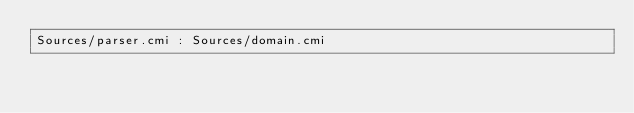<code> <loc_0><loc_0><loc_500><loc_500><_D_>Sources/parser.cmi : Sources/domain.cmi
</code> 